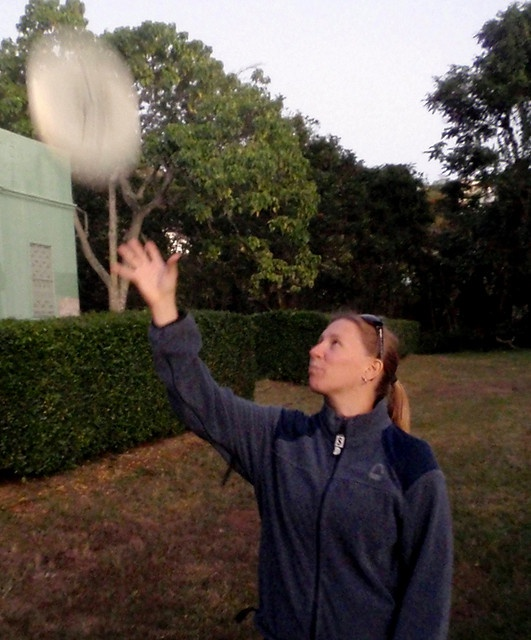Describe the objects in this image and their specific colors. I can see people in lavender, black, salmon, and brown tones and frisbee in lavender, tan, darkgray, and lightgray tones in this image. 